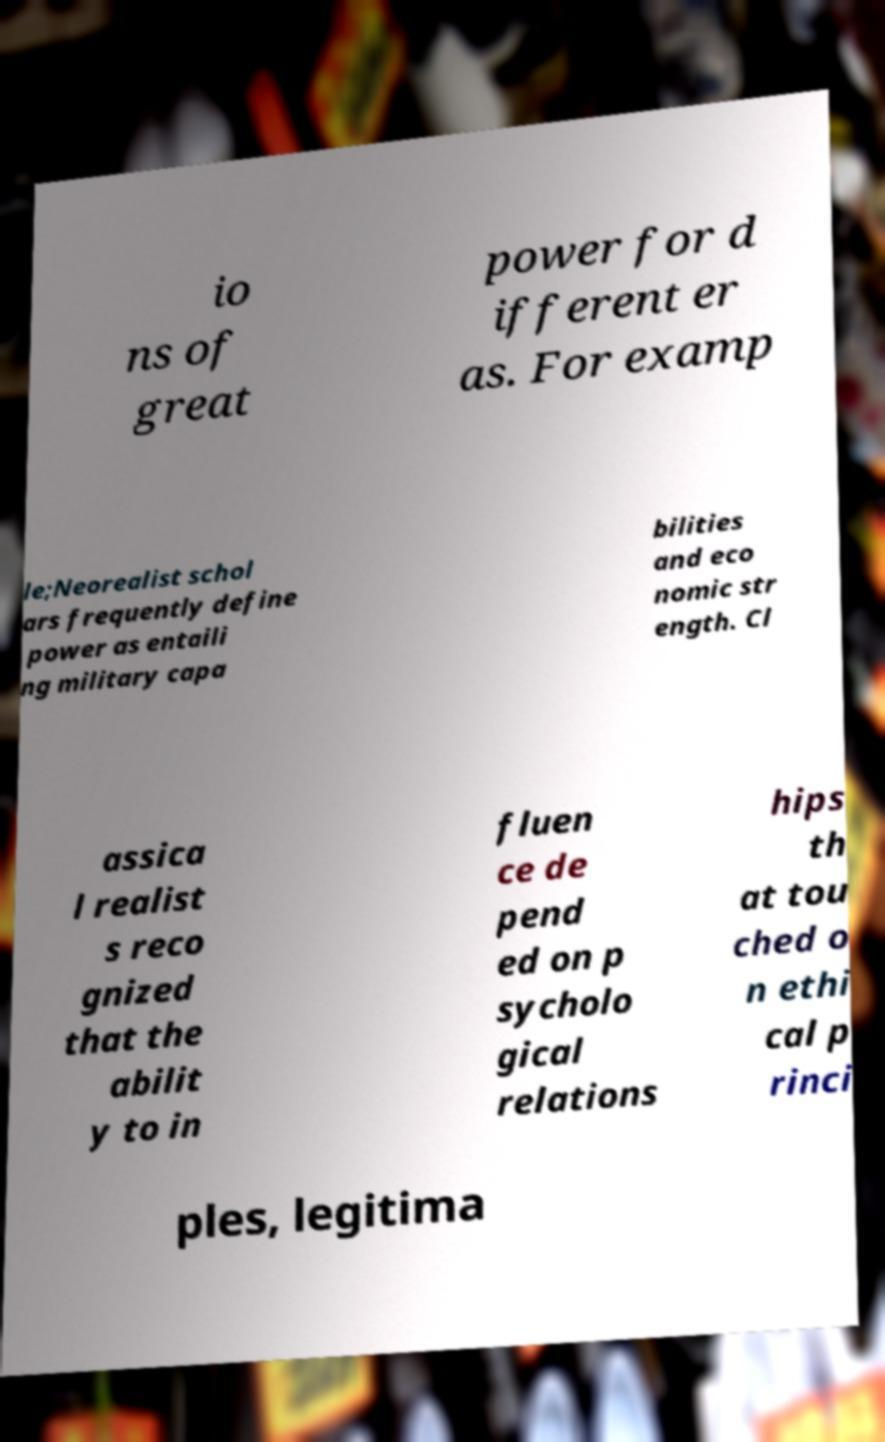There's text embedded in this image that I need extracted. Can you transcribe it verbatim? io ns of great power for d ifferent er as. For examp le;Neorealist schol ars frequently define power as entaili ng military capa bilities and eco nomic str ength. Cl assica l realist s reco gnized that the abilit y to in fluen ce de pend ed on p sycholo gical relations hips th at tou ched o n ethi cal p rinci ples, legitima 